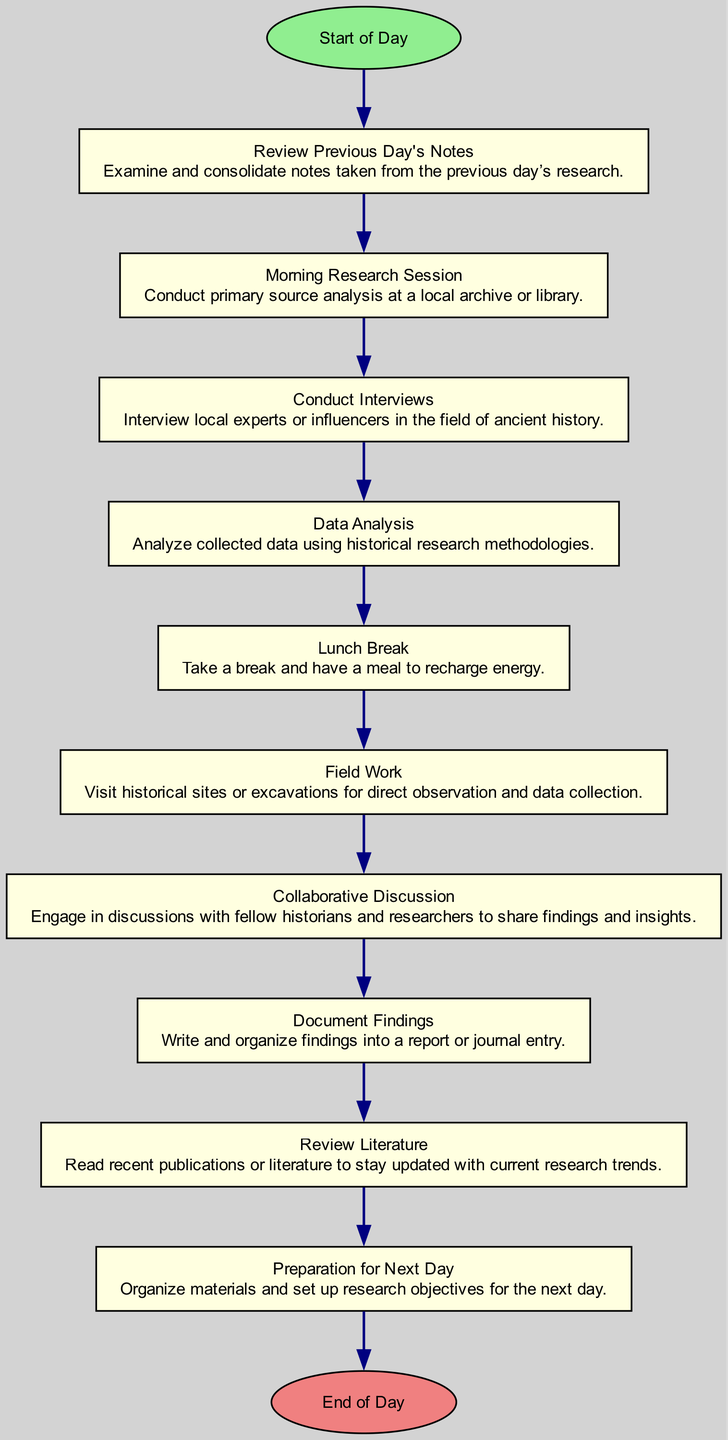What is the first activity in the daily routine? The first activity listed in the diagram is "Review Previous Day's Notes," which follows the starting node "Start of Day."
Answer: Review Previous Day's Notes How many activities are there in total? There are ten activities represented in the diagram between the start and end nodes.
Answer: Ten What activity comes directly after "Conduct Interviews"? The activity that comes directly after "Conduct Interviews" is "Data Analysis."
Answer: Data Analysis Which activity is the last before the end of the day? The last activity before reaching the "End of Day" is "Preparation for Next Day."
Answer: Preparation for Next Day What type of activity follows the "Lunch Break"? The activity that follows "Lunch Break" is a field-based activity, specifically "Field Work."
Answer: Field Work Which two activities are focused on literature? The two activities related to literature include "Review Literature" and "Document Findings," where one involves reading and the other involves writing about research.
Answer: Review Literature and Document Findings Is "Collaborative Discussion" before or after "Data Analysis"? "Collaborative Discussion" occurs after "Data Analysis," as indicated by the sequential flow in the activity diagram.
Answer: After What color is the end node labeled as? The end node is colored light coral as indicated in the diagram attributes.
Answer: Light Coral 